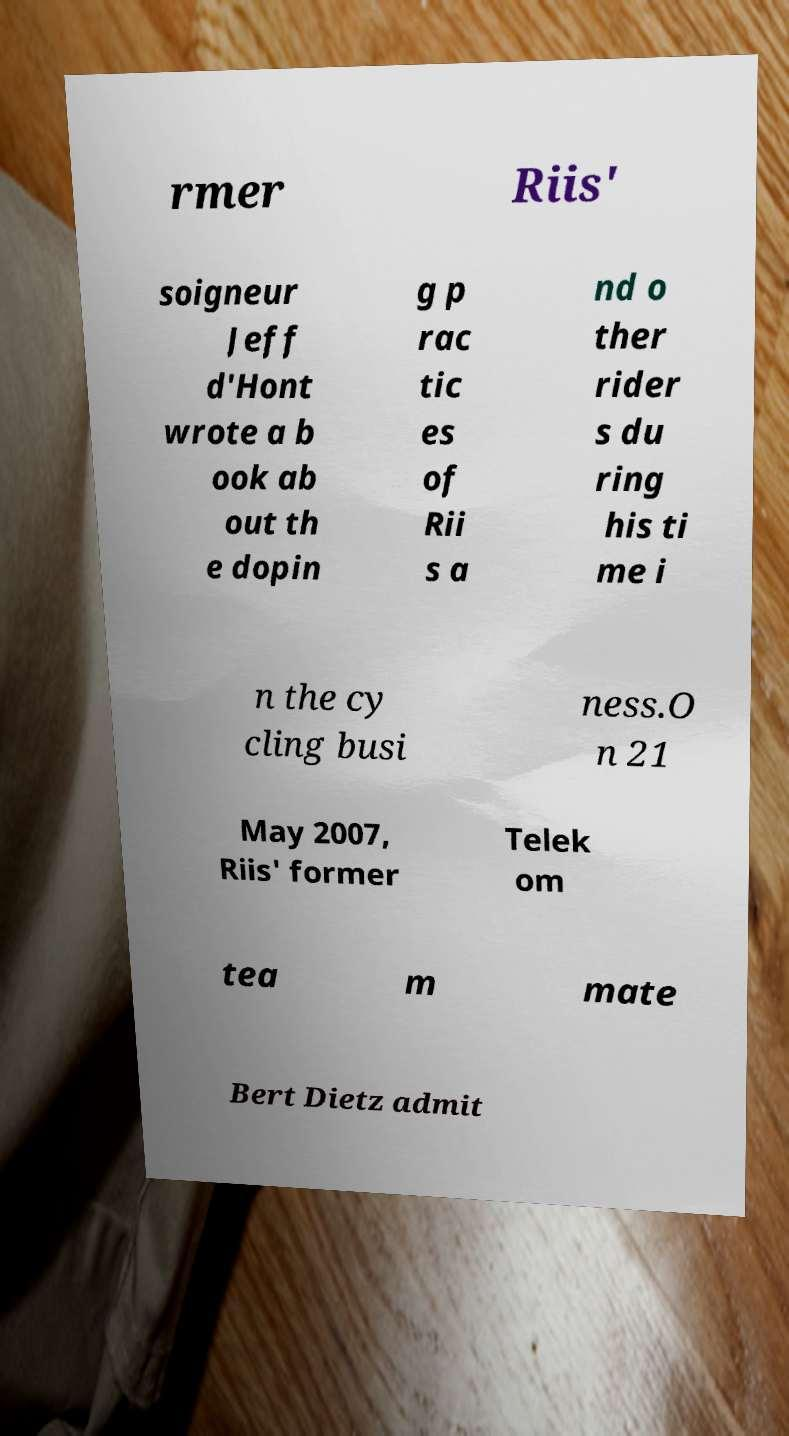Could you extract and type out the text from this image? rmer Riis' soigneur Jeff d'Hont wrote a b ook ab out th e dopin g p rac tic es of Rii s a nd o ther rider s du ring his ti me i n the cy cling busi ness.O n 21 May 2007, Riis' former Telek om tea m mate Bert Dietz admit 